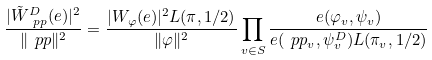Convert formula to latex. <formula><loc_0><loc_0><loc_500><loc_500>\frac { | \tilde { W } _ { \ p p } ^ { D } ( e ) | ^ { 2 } } { \| \ p p \| ^ { 2 } } = \frac { | W _ { \varphi } ( e ) | ^ { 2 } L ( \pi , 1 / 2 ) } { \| \varphi \| ^ { 2 } } \prod _ { v \in S } \frac { e ( \varphi _ { v } , \psi _ { v } ) } { e ( \ p p _ { v } , \psi _ { v } ^ { D } ) L ( \pi _ { v } , 1 / 2 ) }</formula> 